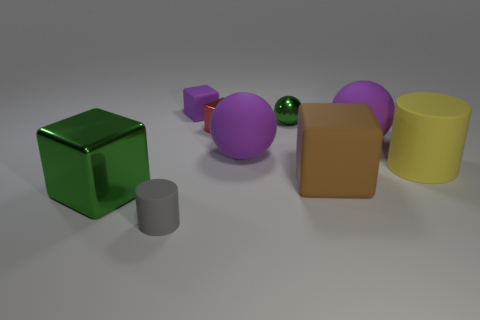Add 1 cyan cylinders. How many objects exist? 10 Subtract all cylinders. How many objects are left? 7 Subtract all small cyan cubes. Subtract all tiny gray cylinders. How many objects are left? 8 Add 2 rubber cylinders. How many rubber cylinders are left? 4 Add 8 tiny red metallic things. How many tiny red metallic things exist? 9 Subtract 1 yellow cylinders. How many objects are left? 8 